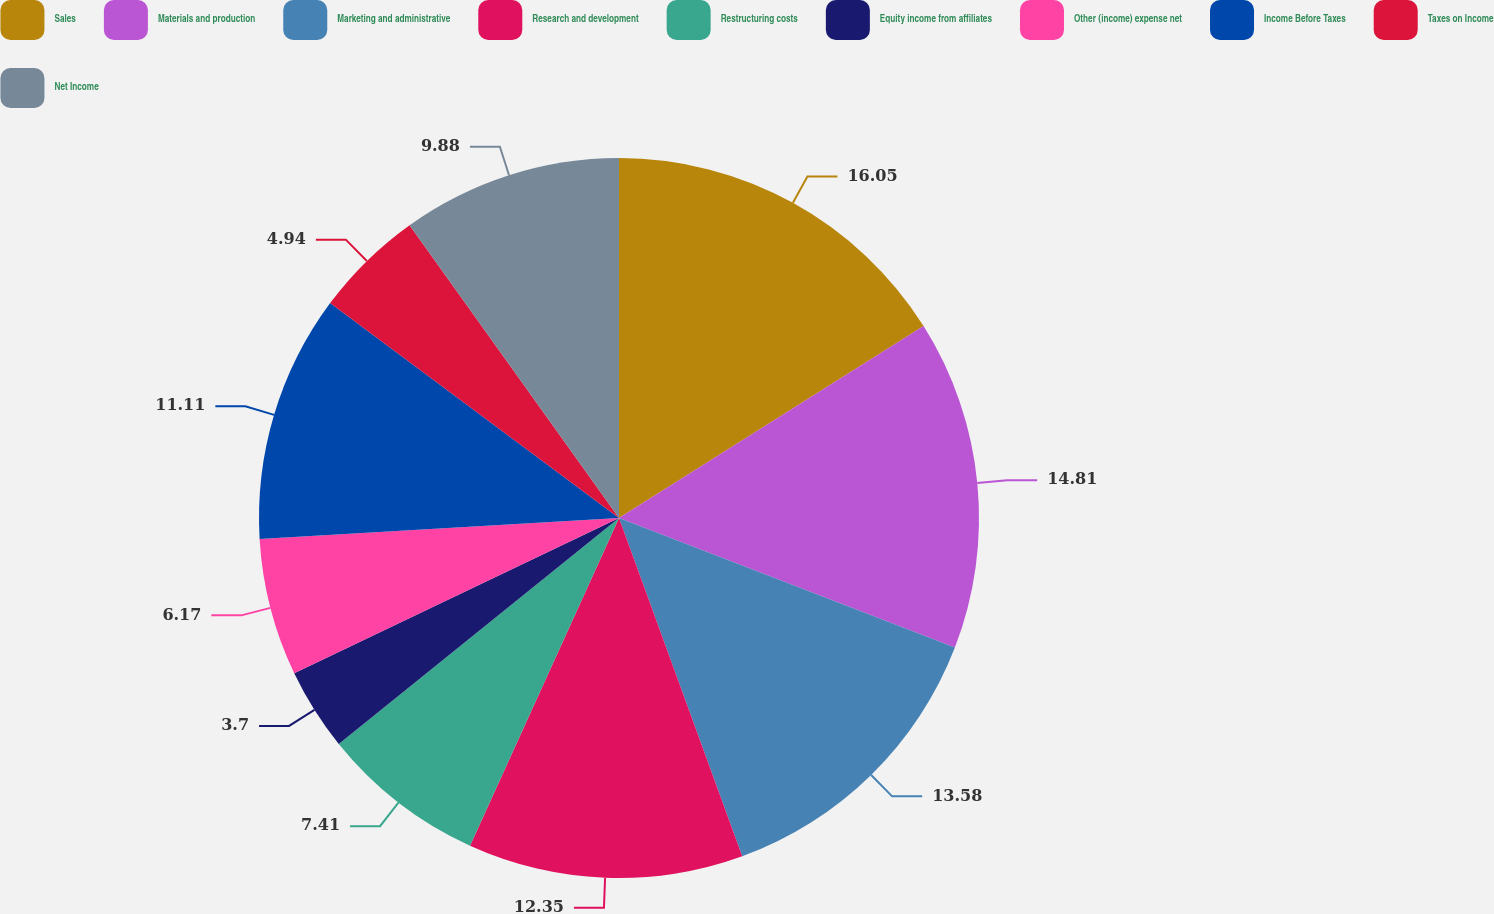Convert chart to OTSL. <chart><loc_0><loc_0><loc_500><loc_500><pie_chart><fcel>Sales<fcel>Materials and production<fcel>Marketing and administrative<fcel>Research and development<fcel>Restructuring costs<fcel>Equity income from affiliates<fcel>Other (income) expense net<fcel>Income Before Taxes<fcel>Taxes on Income<fcel>Net Income<nl><fcel>16.05%<fcel>14.81%<fcel>13.58%<fcel>12.35%<fcel>7.41%<fcel>3.7%<fcel>6.17%<fcel>11.11%<fcel>4.94%<fcel>9.88%<nl></chart> 